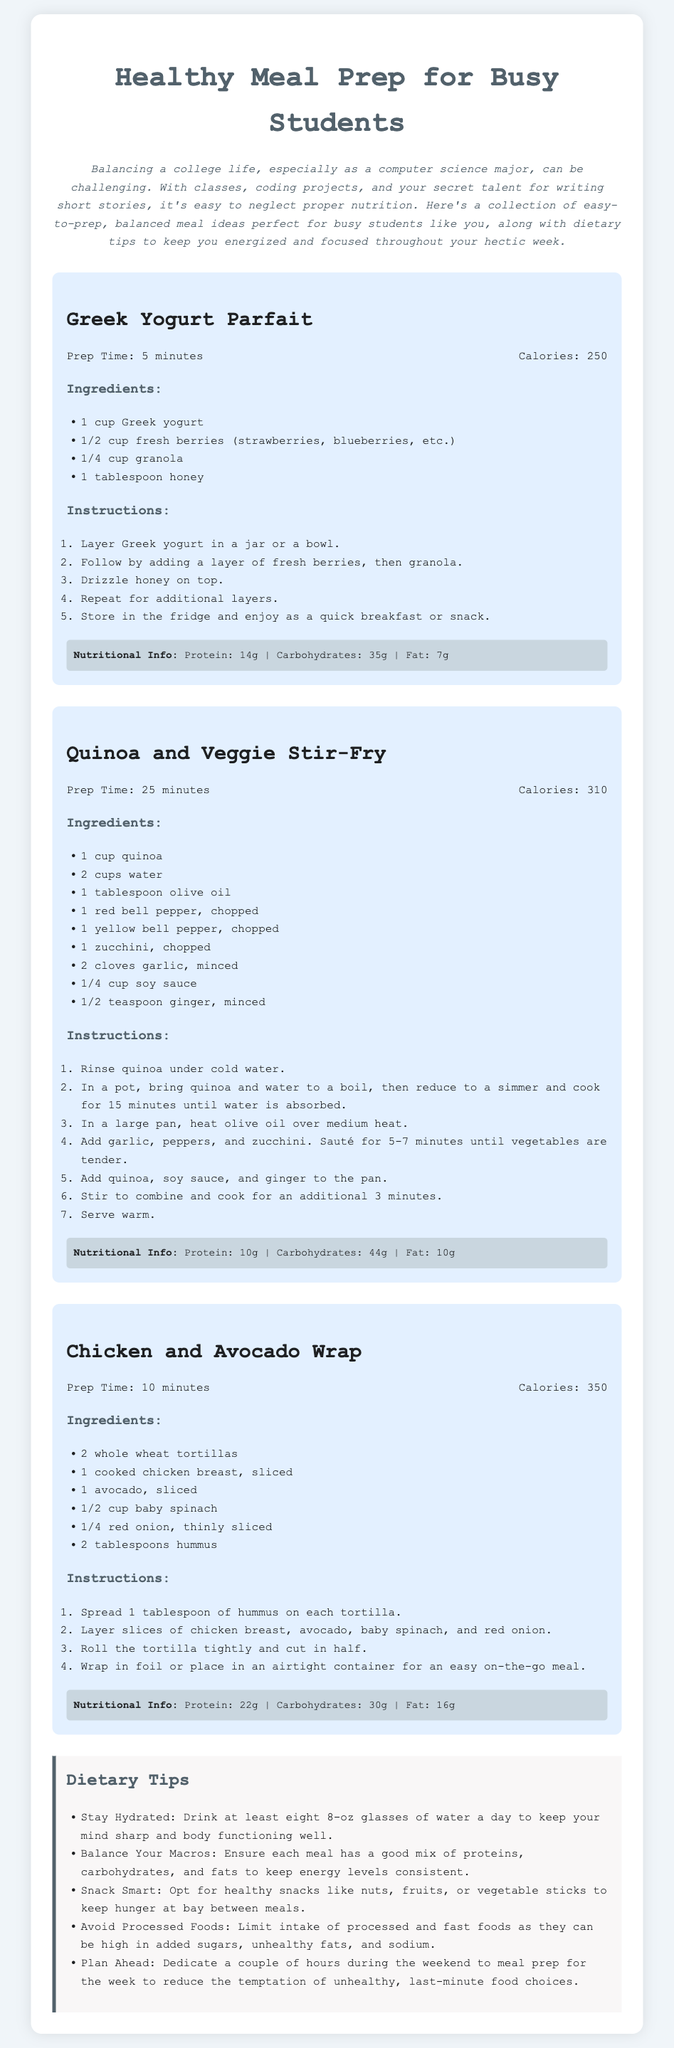what is the total calories for Chicken and Avocado Wrap? The total calories for Chicken and Avocado Wrap is mentioned in the recipe card, which is 350.
Answer: 350 how many minutes does it take to prepare Greek Yogurt Parfait? The prep time for Greek Yogurt Parfait is listed in the recipe card, which is 5 minutes.
Answer: 5 minutes which ingredient is used in Quinoa and Veggie Stir-Fry for flavor? The recipe mentions soy sauce as an ingredient used for flavor in Quinoa and Veggie Stir-Fry.
Answer: soy sauce what is the protein content of Greek Yogurt Parfait? The nutritional information states that Greek Yogurt Parfait has a protein content of 14g.
Answer: 14g how many ingredients are listed for Chicken and Avocado Wrap? The number of ingredients for Chicken and Avocado Wrap can be counted from the ingredients section, which includes 6 items.
Answer: 6 which meal takes the longest to prepare? By comparing the prep times of all meals, Quinoa and Veggie Stir-Fry has the longest prep time at 25 minutes.
Answer: Quinoa and Veggie Stir-Fry what dietary tip suggests avoiding certain foods? The tip about limiting processed and fast foods suggests avoiding these types of foods for better health.
Answer: Avoid Processed Foods what is a healthy snack option according to the tips? The dietary tips suggest nuts, fruits, or vegetable sticks as healthy snack options.
Answer: nuts, fruits, or vegetable sticks how many total recipes are included in the document? There are three recipes provided in the document: Greek Yogurt Parfait, Quinoa and Veggie Stir-Fry, and Chicken and Avocado Wrap.
Answer: 3 